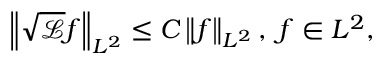Convert formula to latex. <formula><loc_0><loc_0><loc_500><loc_500>\left \| \sqrt { \ m a t h s c r { L } } f \right \| _ { L ^ { 2 } } \leq C \left \| f \right \| _ { L ^ { 2 } } , \, f \in L ^ { 2 } ,</formula> 